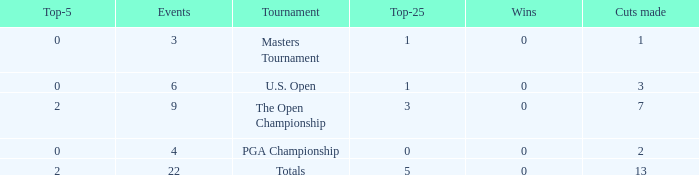What is the average number of cuts made for events with under 4 entries and more than 0 wins? None. 